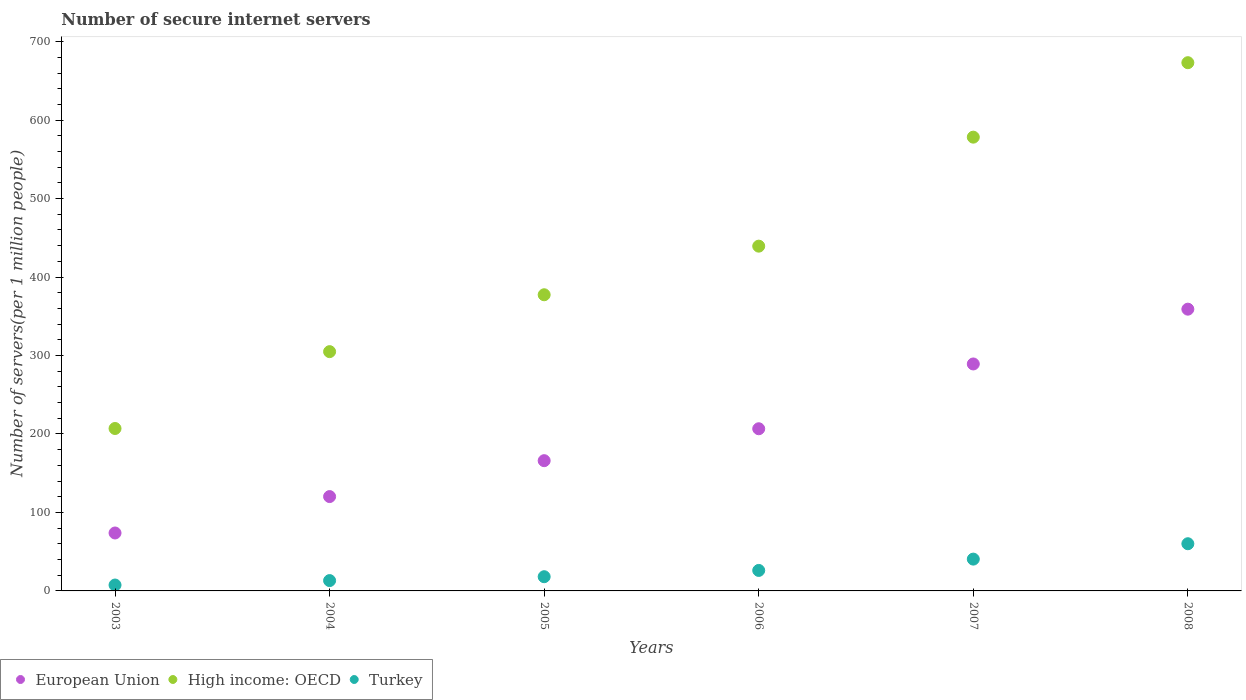How many different coloured dotlines are there?
Offer a terse response. 3. What is the number of secure internet servers in Turkey in 2008?
Provide a short and direct response. 60.13. Across all years, what is the maximum number of secure internet servers in High income: OECD?
Your response must be concise. 673.14. Across all years, what is the minimum number of secure internet servers in Turkey?
Make the answer very short. 7.51. In which year was the number of secure internet servers in Turkey minimum?
Offer a very short reply. 2003. What is the total number of secure internet servers in European Union in the graph?
Provide a short and direct response. 1214.95. What is the difference between the number of secure internet servers in European Union in 2003 and that in 2004?
Your answer should be compact. -46.4. What is the difference between the number of secure internet servers in Turkey in 2004 and the number of secure internet servers in High income: OECD in 2003?
Ensure brevity in your answer.  -193.81. What is the average number of secure internet servers in High income: OECD per year?
Keep it short and to the point. 430.01. In the year 2005, what is the difference between the number of secure internet servers in High income: OECD and number of secure internet servers in Turkey?
Provide a short and direct response. 359.29. What is the ratio of the number of secure internet servers in European Union in 2003 to that in 2005?
Ensure brevity in your answer.  0.44. Is the number of secure internet servers in European Union in 2003 less than that in 2005?
Keep it short and to the point. Yes. Is the difference between the number of secure internet servers in High income: OECD in 2004 and 2005 greater than the difference between the number of secure internet servers in Turkey in 2004 and 2005?
Provide a short and direct response. No. What is the difference between the highest and the second highest number of secure internet servers in High income: OECD?
Provide a short and direct response. 94.89. What is the difference between the highest and the lowest number of secure internet servers in Turkey?
Offer a terse response. 52.62. Is it the case that in every year, the sum of the number of secure internet servers in High income: OECD and number of secure internet servers in Turkey  is greater than the number of secure internet servers in European Union?
Your answer should be compact. Yes. Does the number of secure internet servers in European Union monotonically increase over the years?
Keep it short and to the point. Yes. How many years are there in the graph?
Your answer should be very brief. 6. What is the difference between two consecutive major ticks on the Y-axis?
Keep it short and to the point. 100. Does the graph contain grids?
Make the answer very short. No. Where does the legend appear in the graph?
Your answer should be compact. Bottom left. What is the title of the graph?
Give a very brief answer. Number of secure internet servers. Does "Portugal" appear as one of the legend labels in the graph?
Offer a terse response. No. What is the label or title of the X-axis?
Make the answer very short. Years. What is the label or title of the Y-axis?
Offer a very short reply. Number of servers(per 1 million people). What is the Number of servers(per 1 million people) of European Union in 2003?
Your answer should be very brief. 73.83. What is the Number of servers(per 1 million people) of High income: OECD in 2003?
Offer a very short reply. 206.98. What is the Number of servers(per 1 million people) in Turkey in 2003?
Offer a very short reply. 7.51. What is the Number of servers(per 1 million people) of European Union in 2004?
Give a very brief answer. 120.23. What is the Number of servers(per 1 million people) of High income: OECD in 2004?
Offer a terse response. 304.92. What is the Number of servers(per 1 million people) of Turkey in 2004?
Your answer should be very brief. 13.17. What is the Number of servers(per 1 million people) of European Union in 2005?
Provide a short and direct response. 165.98. What is the Number of servers(per 1 million people) in High income: OECD in 2005?
Your answer should be compact. 377.4. What is the Number of servers(per 1 million people) in Turkey in 2005?
Give a very brief answer. 18.11. What is the Number of servers(per 1 million people) in European Union in 2006?
Give a very brief answer. 206.66. What is the Number of servers(per 1 million people) of High income: OECD in 2006?
Provide a succinct answer. 439.34. What is the Number of servers(per 1 million people) in Turkey in 2006?
Give a very brief answer. 26.11. What is the Number of servers(per 1 million people) of European Union in 2007?
Offer a very short reply. 289.21. What is the Number of servers(per 1 million people) of High income: OECD in 2007?
Provide a succinct answer. 578.25. What is the Number of servers(per 1 million people) of Turkey in 2007?
Ensure brevity in your answer.  40.54. What is the Number of servers(per 1 million people) in European Union in 2008?
Your answer should be compact. 359.04. What is the Number of servers(per 1 million people) of High income: OECD in 2008?
Offer a terse response. 673.14. What is the Number of servers(per 1 million people) in Turkey in 2008?
Provide a short and direct response. 60.13. Across all years, what is the maximum Number of servers(per 1 million people) of European Union?
Ensure brevity in your answer.  359.04. Across all years, what is the maximum Number of servers(per 1 million people) in High income: OECD?
Your response must be concise. 673.14. Across all years, what is the maximum Number of servers(per 1 million people) of Turkey?
Provide a short and direct response. 60.13. Across all years, what is the minimum Number of servers(per 1 million people) of European Union?
Keep it short and to the point. 73.83. Across all years, what is the minimum Number of servers(per 1 million people) in High income: OECD?
Offer a terse response. 206.98. Across all years, what is the minimum Number of servers(per 1 million people) in Turkey?
Give a very brief answer. 7.51. What is the total Number of servers(per 1 million people) in European Union in the graph?
Your response must be concise. 1214.95. What is the total Number of servers(per 1 million people) of High income: OECD in the graph?
Your response must be concise. 2580.04. What is the total Number of servers(per 1 million people) of Turkey in the graph?
Your answer should be very brief. 165.57. What is the difference between the Number of servers(per 1 million people) in European Union in 2003 and that in 2004?
Ensure brevity in your answer.  -46.4. What is the difference between the Number of servers(per 1 million people) in High income: OECD in 2003 and that in 2004?
Provide a short and direct response. -97.94. What is the difference between the Number of servers(per 1 million people) of Turkey in 2003 and that in 2004?
Offer a terse response. -5.66. What is the difference between the Number of servers(per 1 million people) in European Union in 2003 and that in 2005?
Provide a succinct answer. -92.15. What is the difference between the Number of servers(per 1 million people) of High income: OECD in 2003 and that in 2005?
Your answer should be very brief. -170.42. What is the difference between the Number of servers(per 1 million people) in Turkey in 2003 and that in 2005?
Your answer should be very brief. -10.6. What is the difference between the Number of servers(per 1 million people) in European Union in 2003 and that in 2006?
Provide a succinct answer. -132.83. What is the difference between the Number of servers(per 1 million people) in High income: OECD in 2003 and that in 2006?
Provide a short and direct response. -232.36. What is the difference between the Number of servers(per 1 million people) of Turkey in 2003 and that in 2006?
Offer a terse response. -18.6. What is the difference between the Number of servers(per 1 million people) in European Union in 2003 and that in 2007?
Provide a short and direct response. -215.38. What is the difference between the Number of servers(per 1 million people) of High income: OECD in 2003 and that in 2007?
Your answer should be very brief. -371.26. What is the difference between the Number of servers(per 1 million people) of Turkey in 2003 and that in 2007?
Offer a terse response. -33.03. What is the difference between the Number of servers(per 1 million people) in European Union in 2003 and that in 2008?
Offer a very short reply. -285.21. What is the difference between the Number of servers(per 1 million people) of High income: OECD in 2003 and that in 2008?
Ensure brevity in your answer.  -466.15. What is the difference between the Number of servers(per 1 million people) in Turkey in 2003 and that in 2008?
Give a very brief answer. -52.62. What is the difference between the Number of servers(per 1 million people) of European Union in 2004 and that in 2005?
Your answer should be compact. -45.75. What is the difference between the Number of servers(per 1 million people) in High income: OECD in 2004 and that in 2005?
Offer a very short reply. -72.48. What is the difference between the Number of servers(per 1 million people) in Turkey in 2004 and that in 2005?
Provide a short and direct response. -4.94. What is the difference between the Number of servers(per 1 million people) in European Union in 2004 and that in 2006?
Keep it short and to the point. -86.43. What is the difference between the Number of servers(per 1 million people) of High income: OECD in 2004 and that in 2006?
Your answer should be very brief. -134.42. What is the difference between the Number of servers(per 1 million people) of Turkey in 2004 and that in 2006?
Ensure brevity in your answer.  -12.94. What is the difference between the Number of servers(per 1 million people) of European Union in 2004 and that in 2007?
Offer a very short reply. -168.99. What is the difference between the Number of servers(per 1 million people) of High income: OECD in 2004 and that in 2007?
Offer a very short reply. -273.33. What is the difference between the Number of servers(per 1 million people) of Turkey in 2004 and that in 2007?
Offer a terse response. -27.37. What is the difference between the Number of servers(per 1 million people) of European Union in 2004 and that in 2008?
Ensure brevity in your answer.  -238.82. What is the difference between the Number of servers(per 1 million people) in High income: OECD in 2004 and that in 2008?
Your answer should be very brief. -368.21. What is the difference between the Number of servers(per 1 million people) of Turkey in 2004 and that in 2008?
Your answer should be very brief. -46.96. What is the difference between the Number of servers(per 1 million people) of European Union in 2005 and that in 2006?
Provide a short and direct response. -40.68. What is the difference between the Number of servers(per 1 million people) in High income: OECD in 2005 and that in 2006?
Your answer should be very brief. -61.94. What is the difference between the Number of servers(per 1 million people) of Turkey in 2005 and that in 2006?
Provide a succinct answer. -8. What is the difference between the Number of servers(per 1 million people) of European Union in 2005 and that in 2007?
Your answer should be very brief. -123.23. What is the difference between the Number of servers(per 1 million people) of High income: OECD in 2005 and that in 2007?
Ensure brevity in your answer.  -200.85. What is the difference between the Number of servers(per 1 million people) in Turkey in 2005 and that in 2007?
Your response must be concise. -22.43. What is the difference between the Number of servers(per 1 million people) of European Union in 2005 and that in 2008?
Your response must be concise. -193.06. What is the difference between the Number of servers(per 1 million people) in High income: OECD in 2005 and that in 2008?
Your response must be concise. -295.73. What is the difference between the Number of servers(per 1 million people) of Turkey in 2005 and that in 2008?
Your answer should be compact. -42.02. What is the difference between the Number of servers(per 1 million people) of European Union in 2006 and that in 2007?
Offer a terse response. -82.56. What is the difference between the Number of servers(per 1 million people) in High income: OECD in 2006 and that in 2007?
Your response must be concise. -138.9. What is the difference between the Number of servers(per 1 million people) in Turkey in 2006 and that in 2007?
Keep it short and to the point. -14.43. What is the difference between the Number of servers(per 1 million people) of European Union in 2006 and that in 2008?
Your answer should be compact. -152.39. What is the difference between the Number of servers(per 1 million people) of High income: OECD in 2006 and that in 2008?
Make the answer very short. -233.79. What is the difference between the Number of servers(per 1 million people) in Turkey in 2006 and that in 2008?
Offer a terse response. -34.02. What is the difference between the Number of servers(per 1 million people) of European Union in 2007 and that in 2008?
Offer a terse response. -69.83. What is the difference between the Number of servers(per 1 million people) in High income: OECD in 2007 and that in 2008?
Make the answer very short. -94.89. What is the difference between the Number of servers(per 1 million people) in Turkey in 2007 and that in 2008?
Your response must be concise. -19.59. What is the difference between the Number of servers(per 1 million people) in European Union in 2003 and the Number of servers(per 1 million people) in High income: OECD in 2004?
Your response must be concise. -231.09. What is the difference between the Number of servers(per 1 million people) in European Union in 2003 and the Number of servers(per 1 million people) in Turkey in 2004?
Offer a terse response. 60.66. What is the difference between the Number of servers(per 1 million people) in High income: OECD in 2003 and the Number of servers(per 1 million people) in Turkey in 2004?
Offer a terse response. 193.81. What is the difference between the Number of servers(per 1 million people) in European Union in 2003 and the Number of servers(per 1 million people) in High income: OECD in 2005?
Offer a terse response. -303.57. What is the difference between the Number of servers(per 1 million people) of European Union in 2003 and the Number of servers(per 1 million people) of Turkey in 2005?
Give a very brief answer. 55.72. What is the difference between the Number of servers(per 1 million people) of High income: OECD in 2003 and the Number of servers(per 1 million people) of Turkey in 2005?
Provide a short and direct response. 188.87. What is the difference between the Number of servers(per 1 million people) of European Union in 2003 and the Number of servers(per 1 million people) of High income: OECD in 2006?
Offer a very short reply. -365.52. What is the difference between the Number of servers(per 1 million people) of European Union in 2003 and the Number of servers(per 1 million people) of Turkey in 2006?
Your response must be concise. 47.72. What is the difference between the Number of servers(per 1 million people) in High income: OECD in 2003 and the Number of servers(per 1 million people) in Turkey in 2006?
Keep it short and to the point. 180.87. What is the difference between the Number of servers(per 1 million people) of European Union in 2003 and the Number of servers(per 1 million people) of High income: OECD in 2007?
Provide a succinct answer. -504.42. What is the difference between the Number of servers(per 1 million people) in European Union in 2003 and the Number of servers(per 1 million people) in Turkey in 2007?
Provide a succinct answer. 33.29. What is the difference between the Number of servers(per 1 million people) of High income: OECD in 2003 and the Number of servers(per 1 million people) of Turkey in 2007?
Make the answer very short. 166.45. What is the difference between the Number of servers(per 1 million people) of European Union in 2003 and the Number of servers(per 1 million people) of High income: OECD in 2008?
Offer a terse response. -599.31. What is the difference between the Number of servers(per 1 million people) of European Union in 2003 and the Number of servers(per 1 million people) of Turkey in 2008?
Your answer should be compact. 13.7. What is the difference between the Number of servers(per 1 million people) of High income: OECD in 2003 and the Number of servers(per 1 million people) of Turkey in 2008?
Offer a very short reply. 146.85. What is the difference between the Number of servers(per 1 million people) in European Union in 2004 and the Number of servers(per 1 million people) in High income: OECD in 2005?
Your answer should be compact. -257.18. What is the difference between the Number of servers(per 1 million people) in European Union in 2004 and the Number of servers(per 1 million people) in Turkey in 2005?
Give a very brief answer. 102.12. What is the difference between the Number of servers(per 1 million people) in High income: OECD in 2004 and the Number of servers(per 1 million people) in Turkey in 2005?
Your answer should be compact. 286.81. What is the difference between the Number of servers(per 1 million people) of European Union in 2004 and the Number of servers(per 1 million people) of High income: OECD in 2006?
Keep it short and to the point. -319.12. What is the difference between the Number of servers(per 1 million people) in European Union in 2004 and the Number of servers(per 1 million people) in Turkey in 2006?
Ensure brevity in your answer.  94.11. What is the difference between the Number of servers(per 1 million people) in High income: OECD in 2004 and the Number of servers(per 1 million people) in Turkey in 2006?
Ensure brevity in your answer.  278.81. What is the difference between the Number of servers(per 1 million people) of European Union in 2004 and the Number of servers(per 1 million people) of High income: OECD in 2007?
Your response must be concise. -458.02. What is the difference between the Number of servers(per 1 million people) in European Union in 2004 and the Number of servers(per 1 million people) in Turkey in 2007?
Provide a succinct answer. 79.69. What is the difference between the Number of servers(per 1 million people) of High income: OECD in 2004 and the Number of servers(per 1 million people) of Turkey in 2007?
Provide a short and direct response. 264.38. What is the difference between the Number of servers(per 1 million people) in European Union in 2004 and the Number of servers(per 1 million people) in High income: OECD in 2008?
Make the answer very short. -552.91. What is the difference between the Number of servers(per 1 million people) in European Union in 2004 and the Number of servers(per 1 million people) in Turkey in 2008?
Your answer should be compact. 60.09. What is the difference between the Number of servers(per 1 million people) in High income: OECD in 2004 and the Number of servers(per 1 million people) in Turkey in 2008?
Your response must be concise. 244.79. What is the difference between the Number of servers(per 1 million people) in European Union in 2005 and the Number of servers(per 1 million people) in High income: OECD in 2006?
Your answer should be very brief. -273.36. What is the difference between the Number of servers(per 1 million people) of European Union in 2005 and the Number of servers(per 1 million people) of Turkey in 2006?
Offer a terse response. 139.87. What is the difference between the Number of servers(per 1 million people) of High income: OECD in 2005 and the Number of servers(per 1 million people) of Turkey in 2006?
Your answer should be very brief. 351.29. What is the difference between the Number of servers(per 1 million people) of European Union in 2005 and the Number of servers(per 1 million people) of High income: OECD in 2007?
Give a very brief answer. -412.27. What is the difference between the Number of servers(per 1 million people) in European Union in 2005 and the Number of servers(per 1 million people) in Turkey in 2007?
Make the answer very short. 125.44. What is the difference between the Number of servers(per 1 million people) in High income: OECD in 2005 and the Number of servers(per 1 million people) in Turkey in 2007?
Provide a short and direct response. 336.87. What is the difference between the Number of servers(per 1 million people) in European Union in 2005 and the Number of servers(per 1 million people) in High income: OECD in 2008?
Offer a terse response. -507.16. What is the difference between the Number of servers(per 1 million people) of European Union in 2005 and the Number of servers(per 1 million people) of Turkey in 2008?
Make the answer very short. 105.85. What is the difference between the Number of servers(per 1 million people) of High income: OECD in 2005 and the Number of servers(per 1 million people) of Turkey in 2008?
Make the answer very short. 317.27. What is the difference between the Number of servers(per 1 million people) of European Union in 2006 and the Number of servers(per 1 million people) of High income: OECD in 2007?
Your answer should be compact. -371.59. What is the difference between the Number of servers(per 1 million people) in European Union in 2006 and the Number of servers(per 1 million people) in Turkey in 2007?
Your response must be concise. 166.12. What is the difference between the Number of servers(per 1 million people) of High income: OECD in 2006 and the Number of servers(per 1 million people) of Turkey in 2007?
Your answer should be very brief. 398.81. What is the difference between the Number of servers(per 1 million people) in European Union in 2006 and the Number of servers(per 1 million people) in High income: OECD in 2008?
Offer a very short reply. -466.48. What is the difference between the Number of servers(per 1 million people) of European Union in 2006 and the Number of servers(per 1 million people) of Turkey in 2008?
Provide a succinct answer. 146.52. What is the difference between the Number of servers(per 1 million people) in High income: OECD in 2006 and the Number of servers(per 1 million people) in Turkey in 2008?
Keep it short and to the point. 379.21. What is the difference between the Number of servers(per 1 million people) of European Union in 2007 and the Number of servers(per 1 million people) of High income: OECD in 2008?
Your answer should be compact. -383.93. What is the difference between the Number of servers(per 1 million people) of European Union in 2007 and the Number of servers(per 1 million people) of Turkey in 2008?
Make the answer very short. 229.08. What is the difference between the Number of servers(per 1 million people) of High income: OECD in 2007 and the Number of servers(per 1 million people) of Turkey in 2008?
Offer a terse response. 518.12. What is the average Number of servers(per 1 million people) of European Union per year?
Your answer should be compact. 202.49. What is the average Number of servers(per 1 million people) in High income: OECD per year?
Keep it short and to the point. 430.01. What is the average Number of servers(per 1 million people) in Turkey per year?
Give a very brief answer. 27.6. In the year 2003, what is the difference between the Number of servers(per 1 million people) in European Union and Number of servers(per 1 million people) in High income: OECD?
Your answer should be compact. -133.16. In the year 2003, what is the difference between the Number of servers(per 1 million people) of European Union and Number of servers(per 1 million people) of Turkey?
Offer a very short reply. 66.32. In the year 2003, what is the difference between the Number of servers(per 1 million people) in High income: OECD and Number of servers(per 1 million people) in Turkey?
Your answer should be very brief. 199.48. In the year 2004, what is the difference between the Number of servers(per 1 million people) in European Union and Number of servers(per 1 million people) in High income: OECD?
Offer a terse response. -184.7. In the year 2004, what is the difference between the Number of servers(per 1 million people) of European Union and Number of servers(per 1 million people) of Turkey?
Your response must be concise. 107.06. In the year 2004, what is the difference between the Number of servers(per 1 million people) of High income: OECD and Number of servers(per 1 million people) of Turkey?
Ensure brevity in your answer.  291.75. In the year 2005, what is the difference between the Number of servers(per 1 million people) in European Union and Number of servers(per 1 million people) in High income: OECD?
Give a very brief answer. -211.42. In the year 2005, what is the difference between the Number of servers(per 1 million people) of European Union and Number of servers(per 1 million people) of Turkey?
Your answer should be very brief. 147.87. In the year 2005, what is the difference between the Number of servers(per 1 million people) of High income: OECD and Number of servers(per 1 million people) of Turkey?
Make the answer very short. 359.29. In the year 2006, what is the difference between the Number of servers(per 1 million people) of European Union and Number of servers(per 1 million people) of High income: OECD?
Offer a very short reply. -232.69. In the year 2006, what is the difference between the Number of servers(per 1 million people) of European Union and Number of servers(per 1 million people) of Turkey?
Your answer should be very brief. 180.54. In the year 2006, what is the difference between the Number of servers(per 1 million people) in High income: OECD and Number of servers(per 1 million people) in Turkey?
Provide a short and direct response. 413.23. In the year 2007, what is the difference between the Number of servers(per 1 million people) of European Union and Number of servers(per 1 million people) of High income: OECD?
Your answer should be compact. -289.04. In the year 2007, what is the difference between the Number of servers(per 1 million people) in European Union and Number of servers(per 1 million people) in Turkey?
Your answer should be very brief. 248.67. In the year 2007, what is the difference between the Number of servers(per 1 million people) of High income: OECD and Number of servers(per 1 million people) of Turkey?
Give a very brief answer. 537.71. In the year 2008, what is the difference between the Number of servers(per 1 million people) of European Union and Number of servers(per 1 million people) of High income: OECD?
Your response must be concise. -314.09. In the year 2008, what is the difference between the Number of servers(per 1 million people) of European Union and Number of servers(per 1 million people) of Turkey?
Ensure brevity in your answer.  298.91. In the year 2008, what is the difference between the Number of servers(per 1 million people) in High income: OECD and Number of servers(per 1 million people) in Turkey?
Your answer should be compact. 613. What is the ratio of the Number of servers(per 1 million people) of European Union in 2003 to that in 2004?
Provide a succinct answer. 0.61. What is the ratio of the Number of servers(per 1 million people) of High income: OECD in 2003 to that in 2004?
Your response must be concise. 0.68. What is the ratio of the Number of servers(per 1 million people) of Turkey in 2003 to that in 2004?
Make the answer very short. 0.57. What is the ratio of the Number of servers(per 1 million people) in European Union in 2003 to that in 2005?
Make the answer very short. 0.44. What is the ratio of the Number of servers(per 1 million people) in High income: OECD in 2003 to that in 2005?
Your response must be concise. 0.55. What is the ratio of the Number of servers(per 1 million people) of Turkey in 2003 to that in 2005?
Make the answer very short. 0.41. What is the ratio of the Number of servers(per 1 million people) of European Union in 2003 to that in 2006?
Offer a terse response. 0.36. What is the ratio of the Number of servers(per 1 million people) of High income: OECD in 2003 to that in 2006?
Keep it short and to the point. 0.47. What is the ratio of the Number of servers(per 1 million people) of Turkey in 2003 to that in 2006?
Offer a very short reply. 0.29. What is the ratio of the Number of servers(per 1 million people) in European Union in 2003 to that in 2007?
Provide a short and direct response. 0.26. What is the ratio of the Number of servers(per 1 million people) of High income: OECD in 2003 to that in 2007?
Your response must be concise. 0.36. What is the ratio of the Number of servers(per 1 million people) of Turkey in 2003 to that in 2007?
Your response must be concise. 0.19. What is the ratio of the Number of servers(per 1 million people) of European Union in 2003 to that in 2008?
Your answer should be very brief. 0.21. What is the ratio of the Number of servers(per 1 million people) of High income: OECD in 2003 to that in 2008?
Provide a succinct answer. 0.31. What is the ratio of the Number of servers(per 1 million people) in Turkey in 2003 to that in 2008?
Keep it short and to the point. 0.12. What is the ratio of the Number of servers(per 1 million people) in European Union in 2004 to that in 2005?
Offer a terse response. 0.72. What is the ratio of the Number of servers(per 1 million people) of High income: OECD in 2004 to that in 2005?
Your response must be concise. 0.81. What is the ratio of the Number of servers(per 1 million people) of Turkey in 2004 to that in 2005?
Provide a succinct answer. 0.73. What is the ratio of the Number of servers(per 1 million people) of European Union in 2004 to that in 2006?
Make the answer very short. 0.58. What is the ratio of the Number of servers(per 1 million people) of High income: OECD in 2004 to that in 2006?
Ensure brevity in your answer.  0.69. What is the ratio of the Number of servers(per 1 million people) in Turkey in 2004 to that in 2006?
Provide a short and direct response. 0.5. What is the ratio of the Number of servers(per 1 million people) in European Union in 2004 to that in 2007?
Your answer should be compact. 0.42. What is the ratio of the Number of servers(per 1 million people) of High income: OECD in 2004 to that in 2007?
Ensure brevity in your answer.  0.53. What is the ratio of the Number of servers(per 1 million people) of Turkey in 2004 to that in 2007?
Your response must be concise. 0.32. What is the ratio of the Number of servers(per 1 million people) in European Union in 2004 to that in 2008?
Provide a short and direct response. 0.33. What is the ratio of the Number of servers(per 1 million people) in High income: OECD in 2004 to that in 2008?
Ensure brevity in your answer.  0.45. What is the ratio of the Number of servers(per 1 million people) in Turkey in 2004 to that in 2008?
Your answer should be compact. 0.22. What is the ratio of the Number of servers(per 1 million people) of European Union in 2005 to that in 2006?
Give a very brief answer. 0.8. What is the ratio of the Number of servers(per 1 million people) in High income: OECD in 2005 to that in 2006?
Provide a succinct answer. 0.86. What is the ratio of the Number of servers(per 1 million people) in Turkey in 2005 to that in 2006?
Your response must be concise. 0.69. What is the ratio of the Number of servers(per 1 million people) in European Union in 2005 to that in 2007?
Ensure brevity in your answer.  0.57. What is the ratio of the Number of servers(per 1 million people) in High income: OECD in 2005 to that in 2007?
Your answer should be compact. 0.65. What is the ratio of the Number of servers(per 1 million people) in Turkey in 2005 to that in 2007?
Your response must be concise. 0.45. What is the ratio of the Number of servers(per 1 million people) in European Union in 2005 to that in 2008?
Make the answer very short. 0.46. What is the ratio of the Number of servers(per 1 million people) of High income: OECD in 2005 to that in 2008?
Offer a very short reply. 0.56. What is the ratio of the Number of servers(per 1 million people) of Turkey in 2005 to that in 2008?
Your answer should be very brief. 0.3. What is the ratio of the Number of servers(per 1 million people) in European Union in 2006 to that in 2007?
Your response must be concise. 0.71. What is the ratio of the Number of servers(per 1 million people) of High income: OECD in 2006 to that in 2007?
Offer a very short reply. 0.76. What is the ratio of the Number of servers(per 1 million people) in Turkey in 2006 to that in 2007?
Offer a terse response. 0.64. What is the ratio of the Number of servers(per 1 million people) of European Union in 2006 to that in 2008?
Provide a succinct answer. 0.58. What is the ratio of the Number of servers(per 1 million people) of High income: OECD in 2006 to that in 2008?
Your answer should be very brief. 0.65. What is the ratio of the Number of servers(per 1 million people) in Turkey in 2006 to that in 2008?
Provide a short and direct response. 0.43. What is the ratio of the Number of servers(per 1 million people) of European Union in 2007 to that in 2008?
Give a very brief answer. 0.81. What is the ratio of the Number of servers(per 1 million people) in High income: OECD in 2007 to that in 2008?
Your response must be concise. 0.86. What is the ratio of the Number of servers(per 1 million people) in Turkey in 2007 to that in 2008?
Provide a short and direct response. 0.67. What is the difference between the highest and the second highest Number of servers(per 1 million people) in European Union?
Your answer should be very brief. 69.83. What is the difference between the highest and the second highest Number of servers(per 1 million people) in High income: OECD?
Provide a succinct answer. 94.89. What is the difference between the highest and the second highest Number of servers(per 1 million people) of Turkey?
Your answer should be very brief. 19.59. What is the difference between the highest and the lowest Number of servers(per 1 million people) of European Union?
Give a very brief answer. 285.21. What is the difference between the highest and the lowest Number of servers(per 1 million people) of High income: OECD?
Ensure brevity in your answer.  466.15. What is the difference between the highest and the lowest Number of servers(per 1 million people) of Turkey?
Your answer should be very brief. 52.62. 